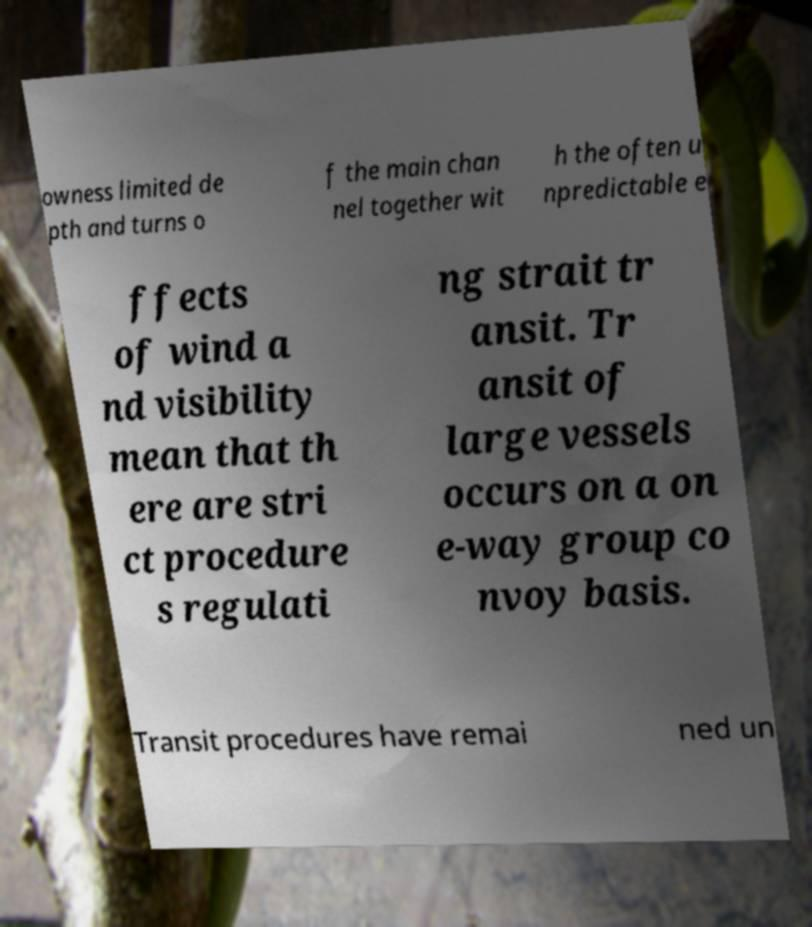Can you read and provide the text displayed in the image?This photo seems to have some interesting text. Can you extract and type it out for me? owness limited de pth and turns o f the main chan nel together wit h the often u npredictable e ffects of wind a nd visibility mean that th ere are stri ct procedure s regulati ng strait tr ansit. Tr ansit of large vessels occurs on a on e-way group co nvoy basis. Transit procedures have remai ned un 